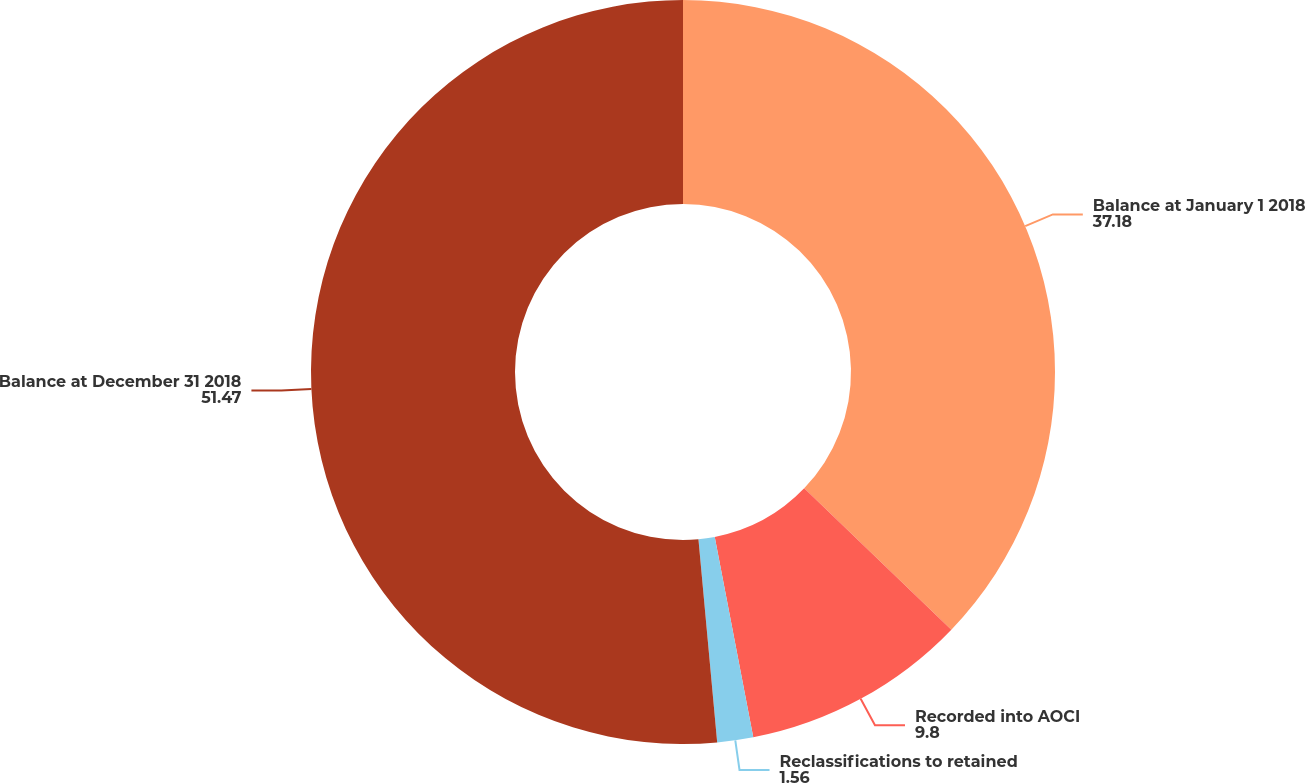Convert chart. <chart><loc_0><loc_0><loc_500><loc_500><pie_chart><fcel>Balance at January 1 2018<fcel>Recorded into AOCI<fcel>Reclassifications to retained<fcel>Balance at December 31 2018<nl><fcel>37.18%<fcel>9.8%<fcel>1.56%<fcel>51.47%<nl></chart> 